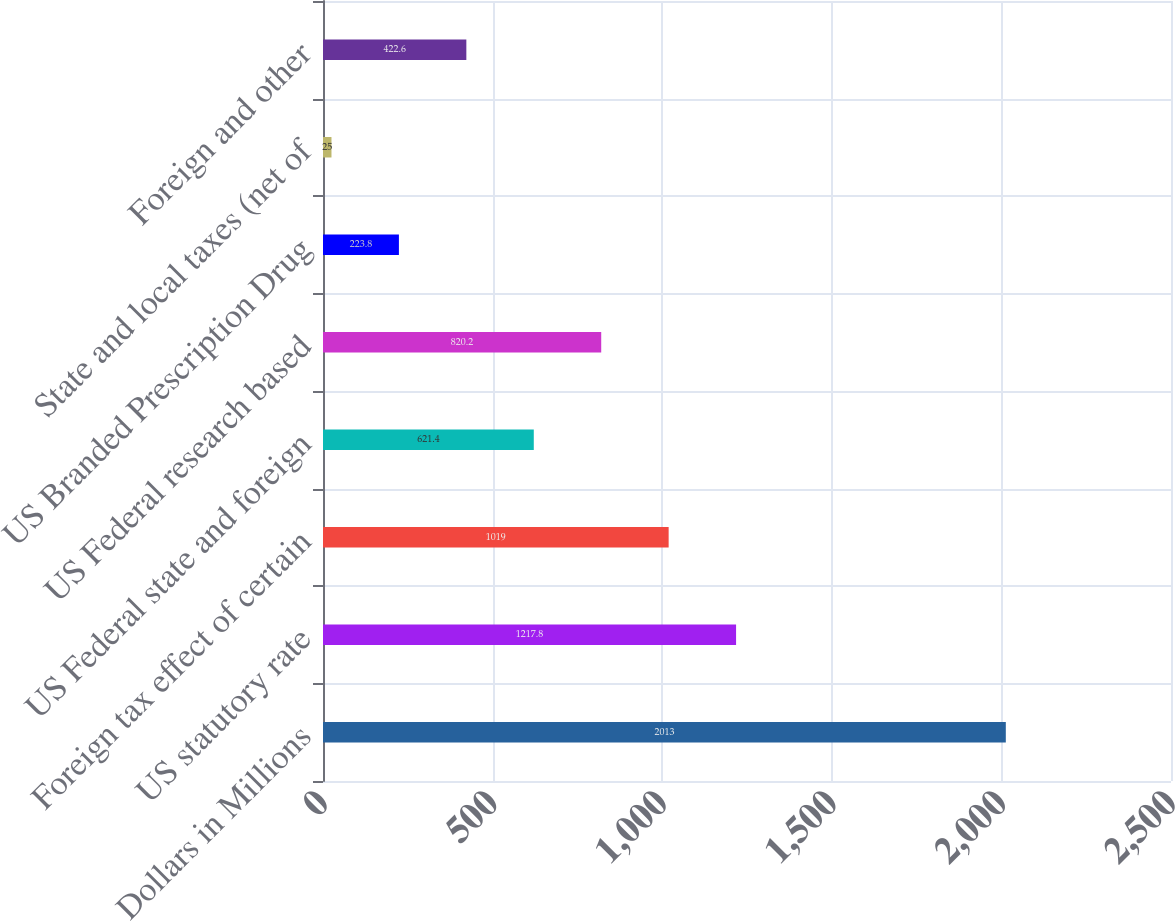Convert chart to OTSL. <chart><loc_0><loc_0><loc_500><loc_500><bar_chart><fcel>Dollars in Millions<fcel>US statutory rate<fcel>Foreign tax effect of certain<fcel>US Federal state and foreign<fcel>US Federal research based<fcel>US Branded Prescription Drug<fcel>State and local taxes (net of<fcel>Foreign and other<nl><fcel>2013<fcel>1217.8<fcel>1019<fcel>621.4<fcel>820.2<fcel>223.8<fcel>25<fcel>422.6<nl></chart> 